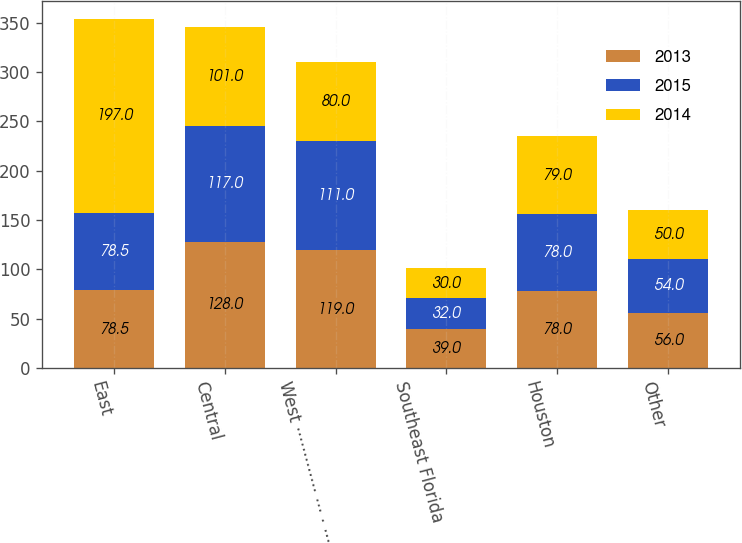<chart> <loc_0><loc_0><loc_500><loc_500><stacked_bar_chart><ecel><fcel>East<fcel>Central<fcel>West ············· ··· · ···<fcel>Southeast Florida<fcel>Houston<fcel>Other<nl><fcel>2013<fcel>78.5<fcel>128<fcel>119<fcel>39<fcel>78<fcel>56<nl><fcel>2015<fcel>78.5<fcel>117<fcel>111<fcel>32<fcel>78<fcel>54<nl><fcel>2014<fcel>197<fcel>101<fcel>80<fcel>30<fcel>79<fcel>50<nl></chart> 